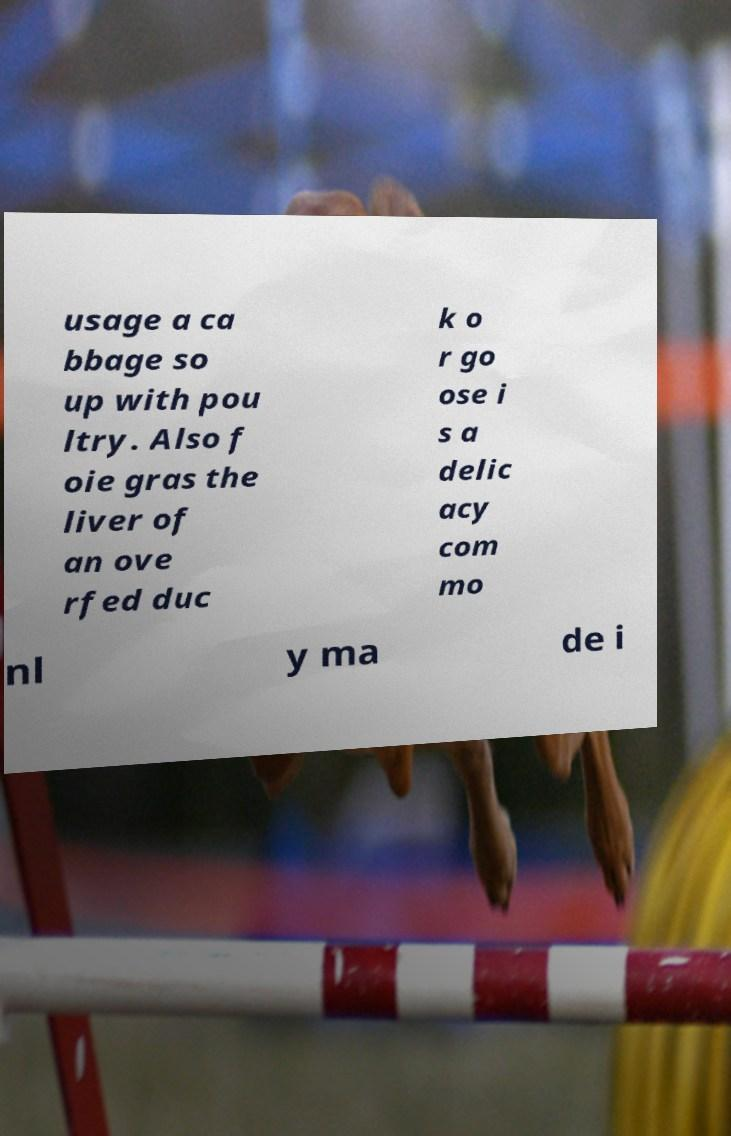Can you read and provide the text displayed in the image?This photo seems to have some interesting text. Can you extract and type it out for me? usage a ca bbage so up with pou ltry. Also f oie gras the liver of an ove rfed duc k o r go ose i s a delic acy com mo nl y ma de i 